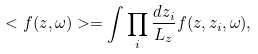<formula> <loc_0><loc_0><loc_500><loc_500>< f ( z , \omega ) > = \int \prod _ { i } \frac { d z _ { i } } { L _ { z } } f ( z , { z _ { i } } , \omega ) ,</formula> 